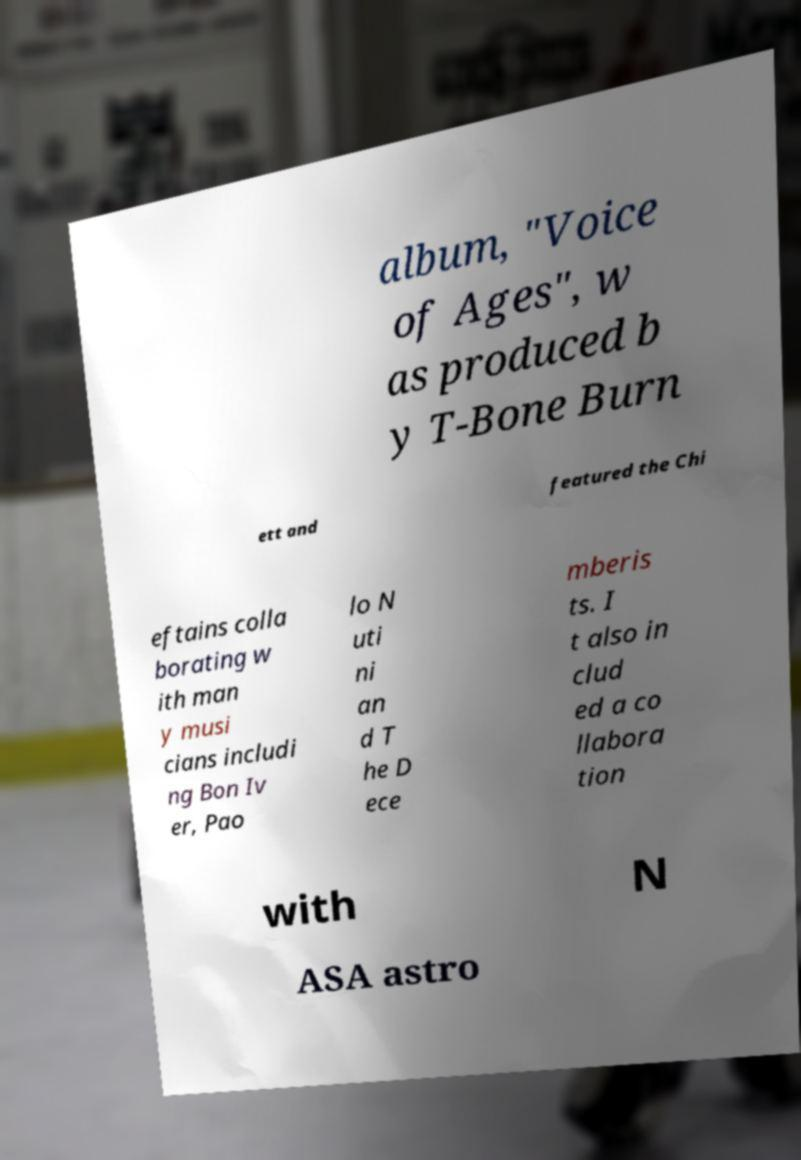For documentation purposes, I need the text within this image transcribed. Could you provide that? album, "Voice of Ages", w as produced b y T-Bone Burn ett and featured the Chi eftains colla borating w ith man y musi cians includi ng Bon Iv er, Pao lo N uti ni an d T he D ece mberis ts. I t also in clud ed a co llabora tion with N ASA astro 